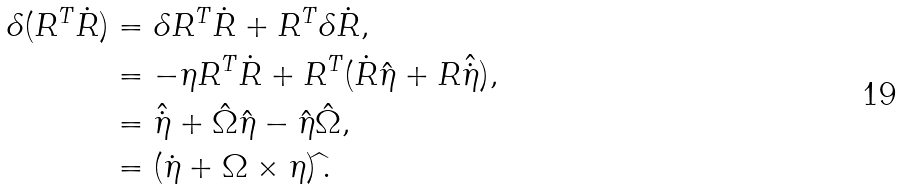Convert formula to latex. <formula><loc_0><loc_0><loc_500><loc_500>\delta ( R ^ { T } \dot { R } ) & = \delta R ^ { T } \dot { R } + R ^ { T } \delta \dot { R } , \\ & = - \eta R ^ { T } \dot { R } + R ^ { T } ( \dot { R } \hat { \eta } + R \hat { \dot { \eta } } ) , \\ & = \hat { \dot { \eta } } + \hat { \Omega } \hat { \eta } - \hat { \eta } \hat { \Omega } , \\ & = ( \dot { \eta } + \Omega \times \eta ) \widehat { \, } .</formula> 